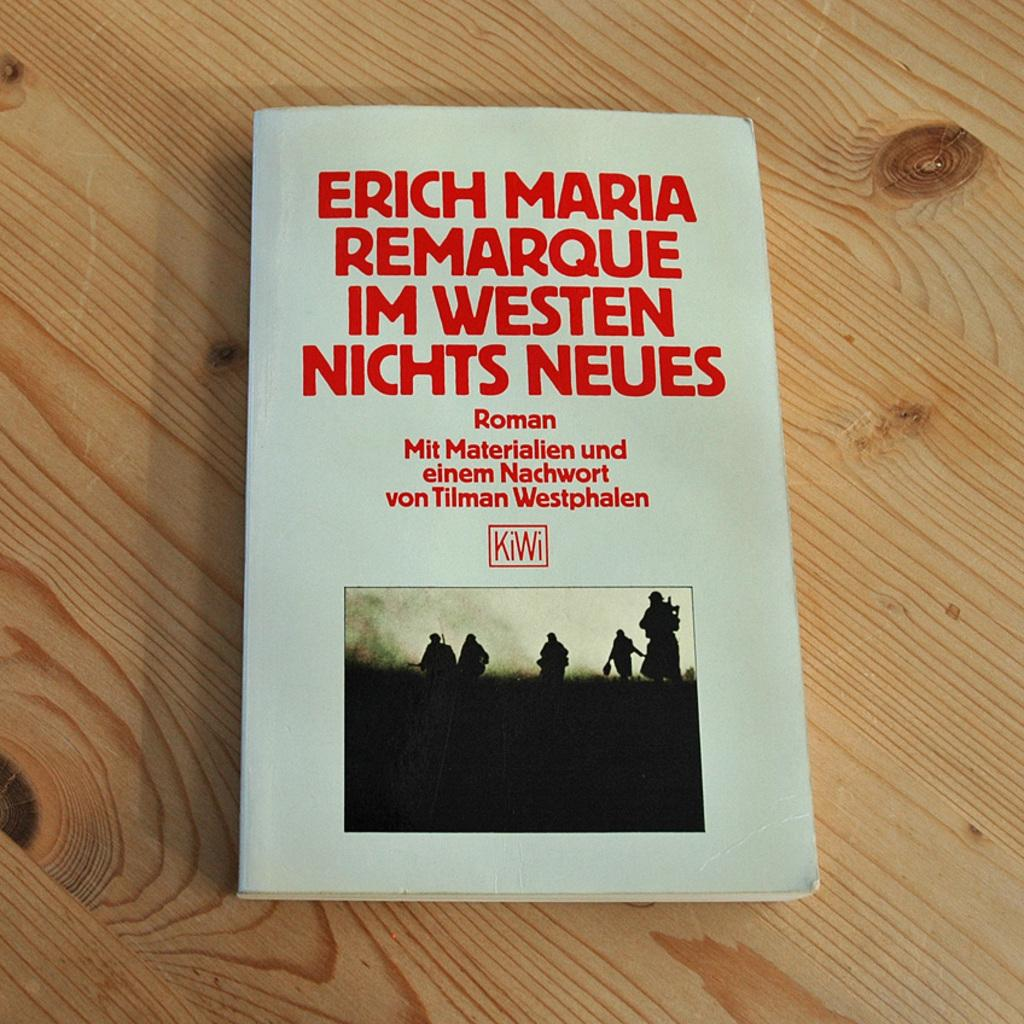What object is present on a wooden surface in the image? There is a book on a wooden surface in the image. What can be found on the book? The book has text and an image on it. Who or what can be seen in the image besides the book? There are persons visible in the image. What part of the natural environment is visible in the image? The sky is visible in the image. What type of brush is being used by the ant in the image? There is no ant or brush present in the image. 